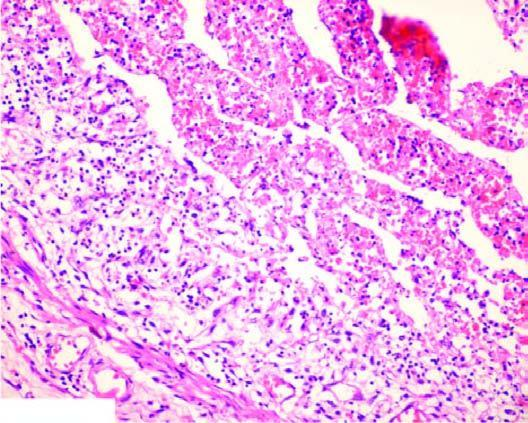what is occluded by a thrombus containing microabscesses?
Answer the question using a single word or phrase. The lumen 